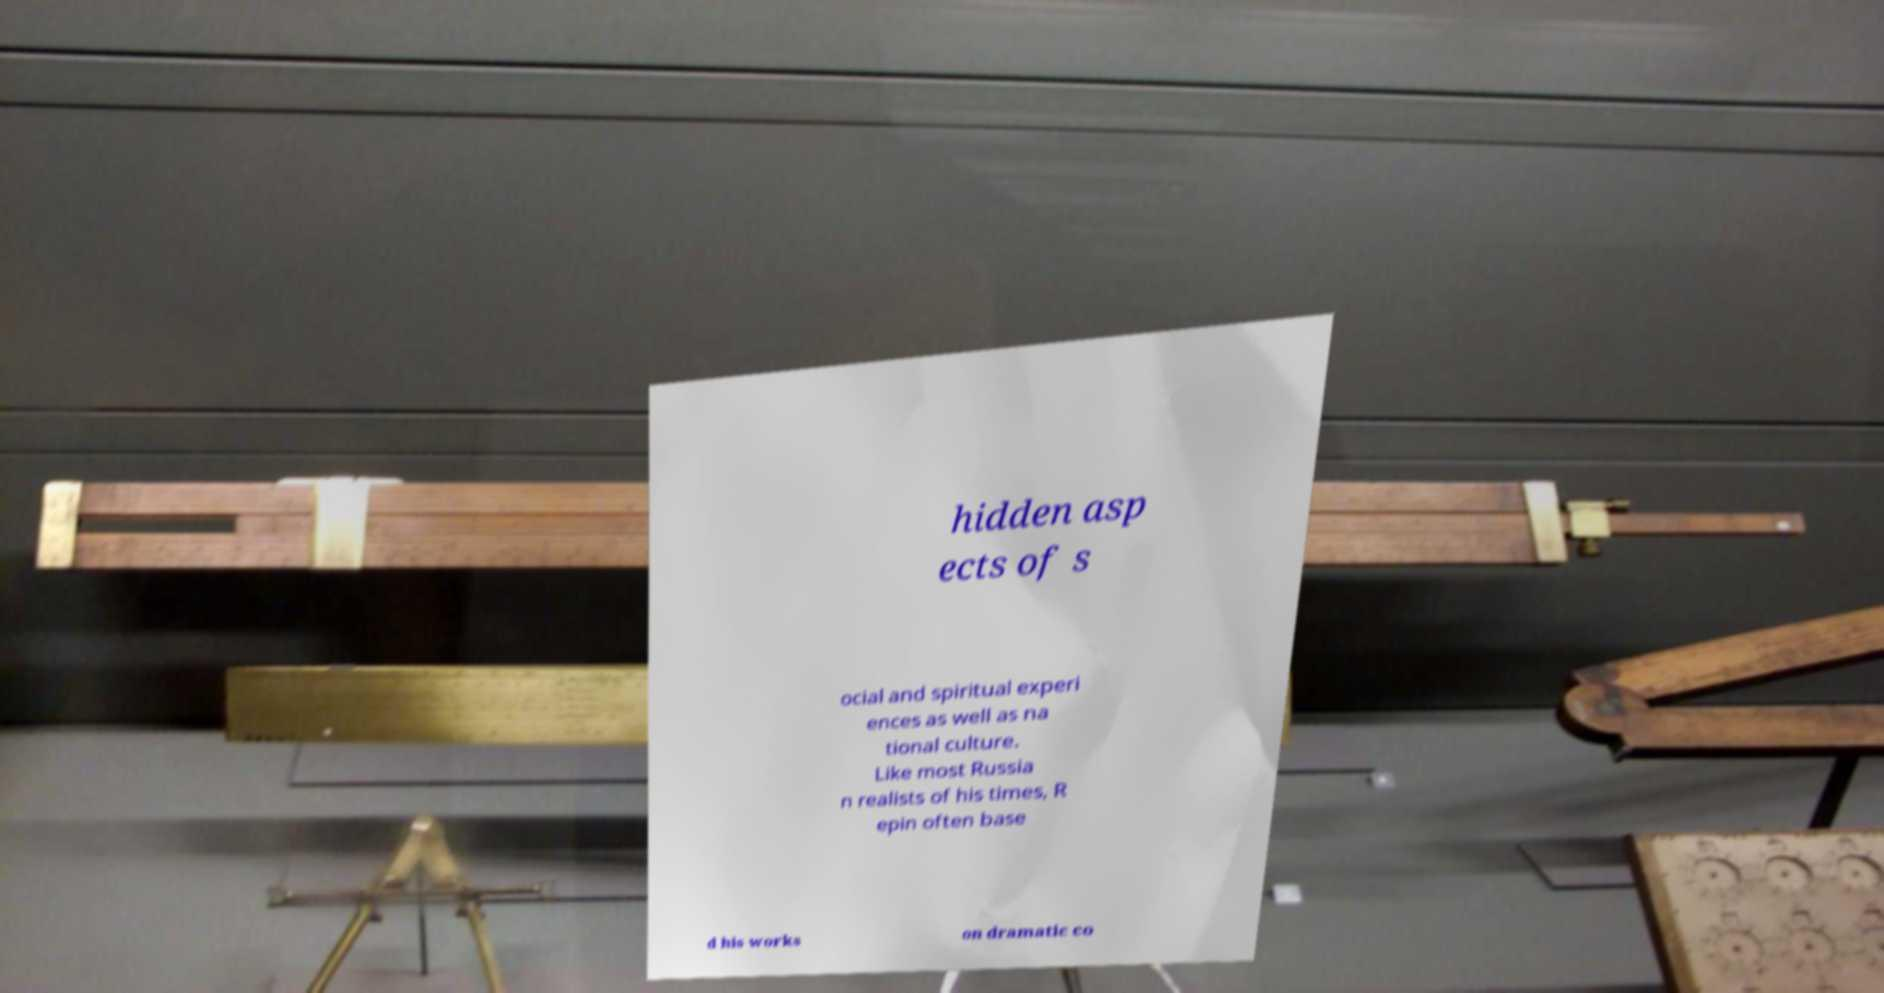For documentation purposes, I need the text within this image transcribed. Could you provide that? hidden asp ects of s ocial and spiritual experi ences as well as na tional culture. Like most Russia n realists of his times, R epin often base d his works on dramatic co 